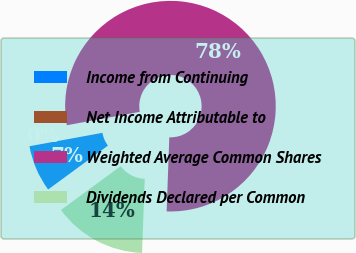Convert chart. <chart><loc_0><loc_0><loc_500><loc_500><pie_chart><fcel>Income from Continuing<fcel>Net Income Attributable to<fcel>Weighted Average Common Shares<fcel>Dividends Declared per Common<nl><fcel>7.18%<fcel>0.0%<fcel>78.47%<fcel>14.35%<nl></chart> 